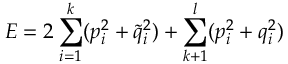<formula> <loc_0><loc_0><loc_500><loc_500>E = 2 \sum _ { i = 1 } ^ { k } ( p _ { i } ^ { 2 } + \tilde { q } _ { i } ^ { 2 } ) + \sum _ { k + 1 } ^ { l } ( p _ { i } ^ { 2 } + q _ { i } ^ { 2 } )</formula> 